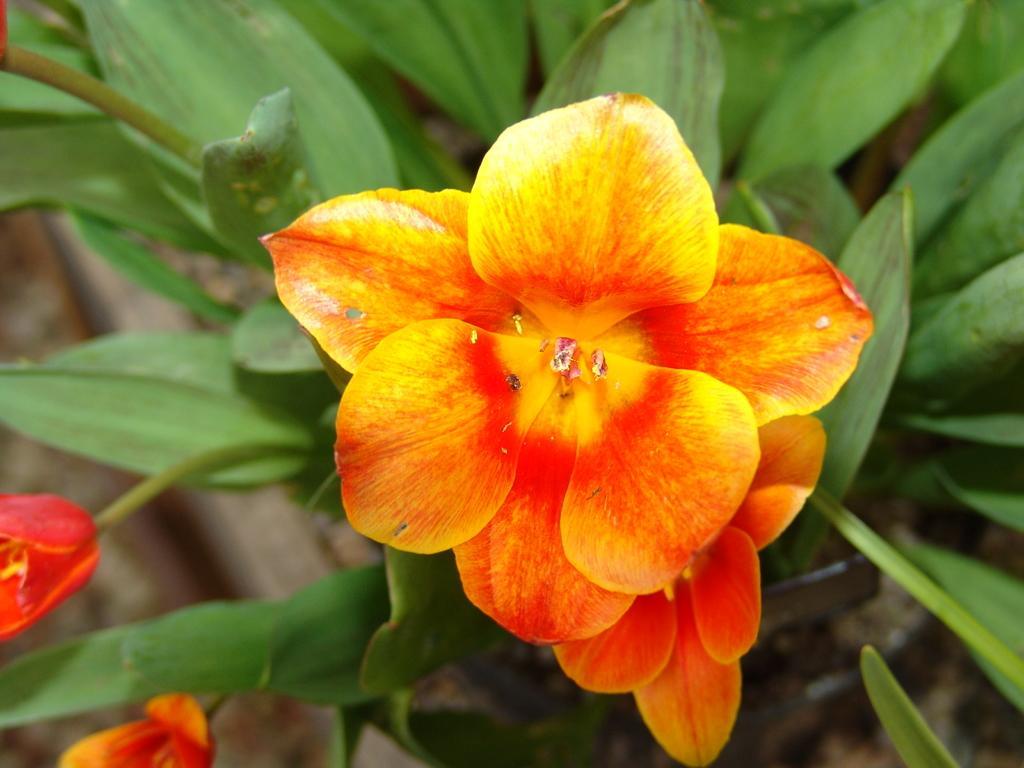Describe this image in one or two sentences. Here we can see a plant with flowers. 